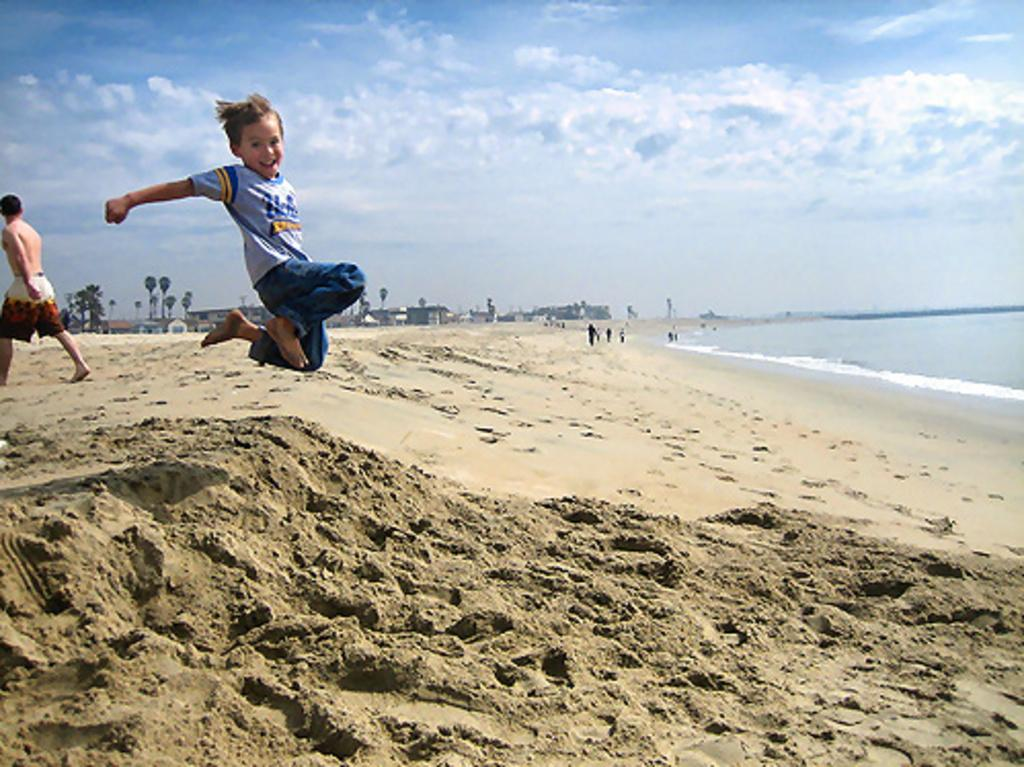Who or what can be seen in the image? There are people in the image. What type of natural elements are present in the image? There are trees and water visible in the image. What type of structures can be seen in the image? There are houses in the image. What is visible in the background of the image? The sky is visible in the background of the image. What type of nest can be seen in the image? There is no nest present in the image. Can you hear the voice of the parent in the image? There is no voice or parent present in the image, as it is a still image and not a video or audio recording. 